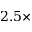Convert formula to latex. <formula><loc_0><loc_0><loc_500><loc_500>2 . 5 \times</formula> 